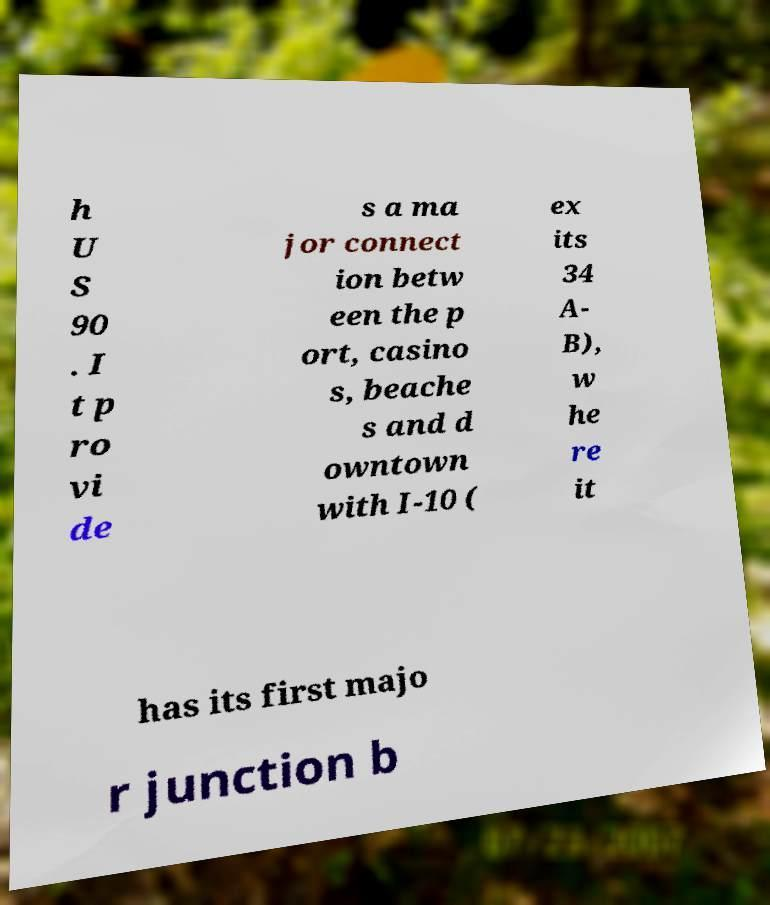Could you assist in decoding the text presented in this image and type it out clearly? h U S 90 . I t p ro vi de s a ma jor connect ion betw een the p ort, casino s, beache s and d owntown with I-10 ( ex its 34 A- B), w he re it has its first majo r junction b 